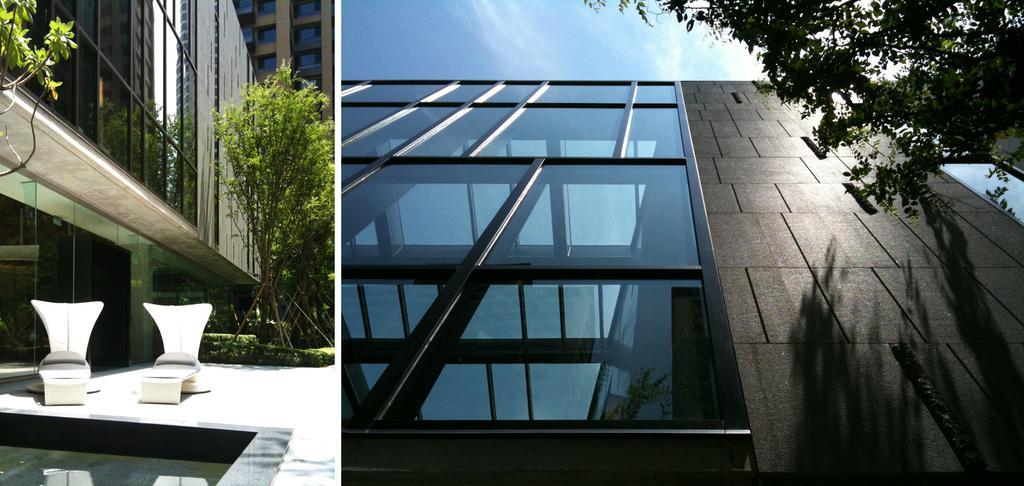How would you summarize this image in a sentence or two? There are two images. In the first image, there are two chairs, arranged on the floor, near a swimming pool and building, which is having glass windows, which is near plants and trees. In the background, there is a building. In the second image, there is a building, which is having glass windows, near a tree. In the background, there are clouds in the blue sky. 